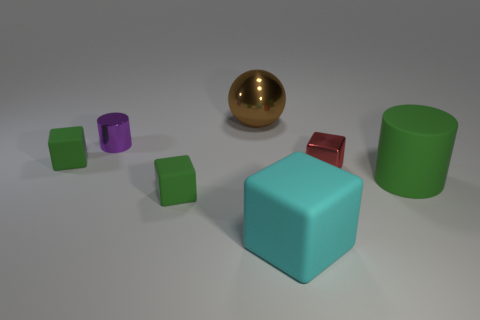Which object stands out the most based on its material? The spherical golden object stands out the most due to its reflective metallic surface, which contrasts with the matte textures of the other objects. 